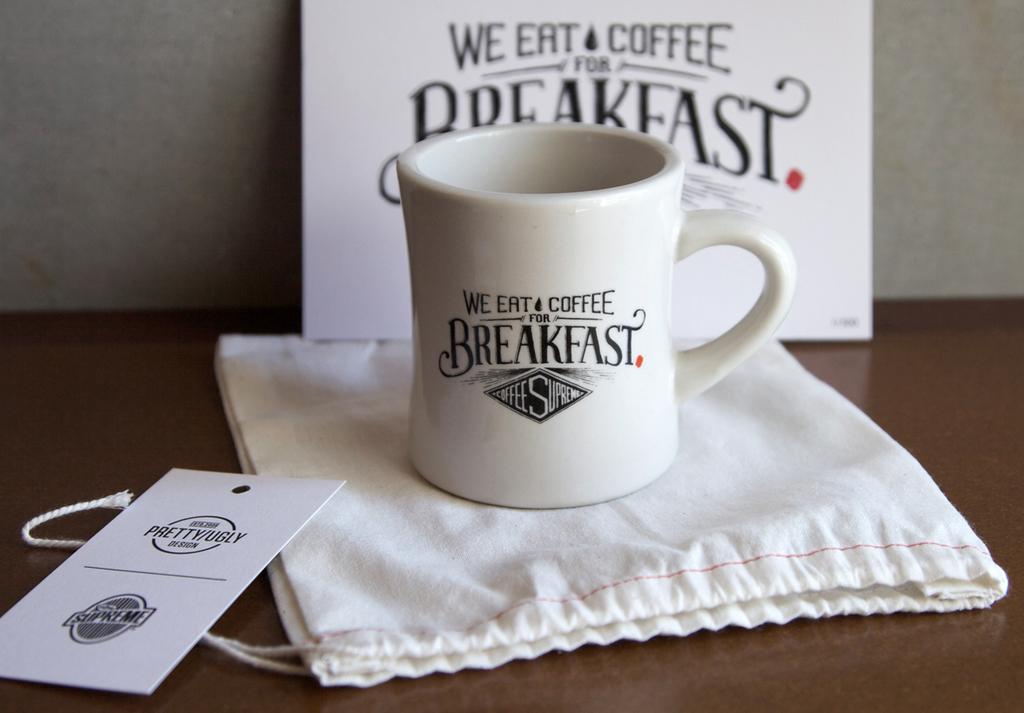What meal is this mug promoting?
Provide a short and direct response. Breakfast. 